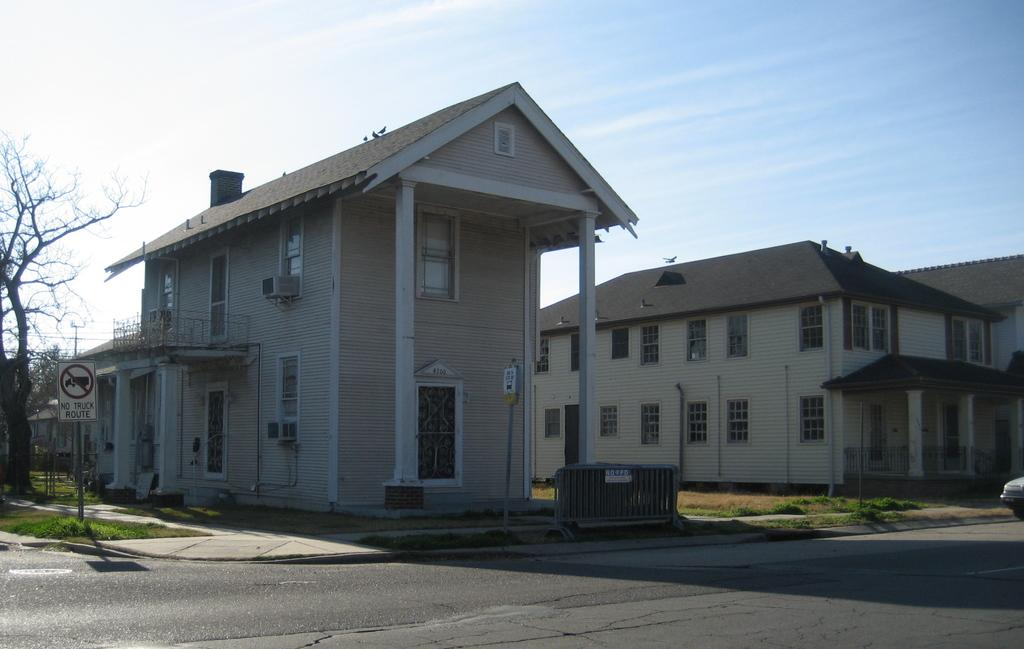What type of surface can be seen in the image? There is a road in the image. What type of vegetation is present in the image? There is grass in the image. What type of structure is present in the image? There is a signboard in the image. What type of barrier is present in the image? There are fences in the image. What type of vertical structures are present in the image? There are poles in the image. What type of natural elements are present in the image? There are trees in the image. What type of living creatures are present in the image? There are birds in the image. What type of structures with openings are present in the image? There are buildings with windows in the image. What type of unspecified objects are present in the image? There are some objects in the image. What can be seen in the background of the image? The sky is visible in the background of the image. Is there any snow visible in the image? No, there is no snow present in the image. What type of iron objects can be seen in the image? There is no mention of iron objects in the image, so we cannot determine if any are present. 